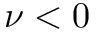<formula> <loc_0><loc_0><loc_500><loc_500>\nu < 0</formula> 